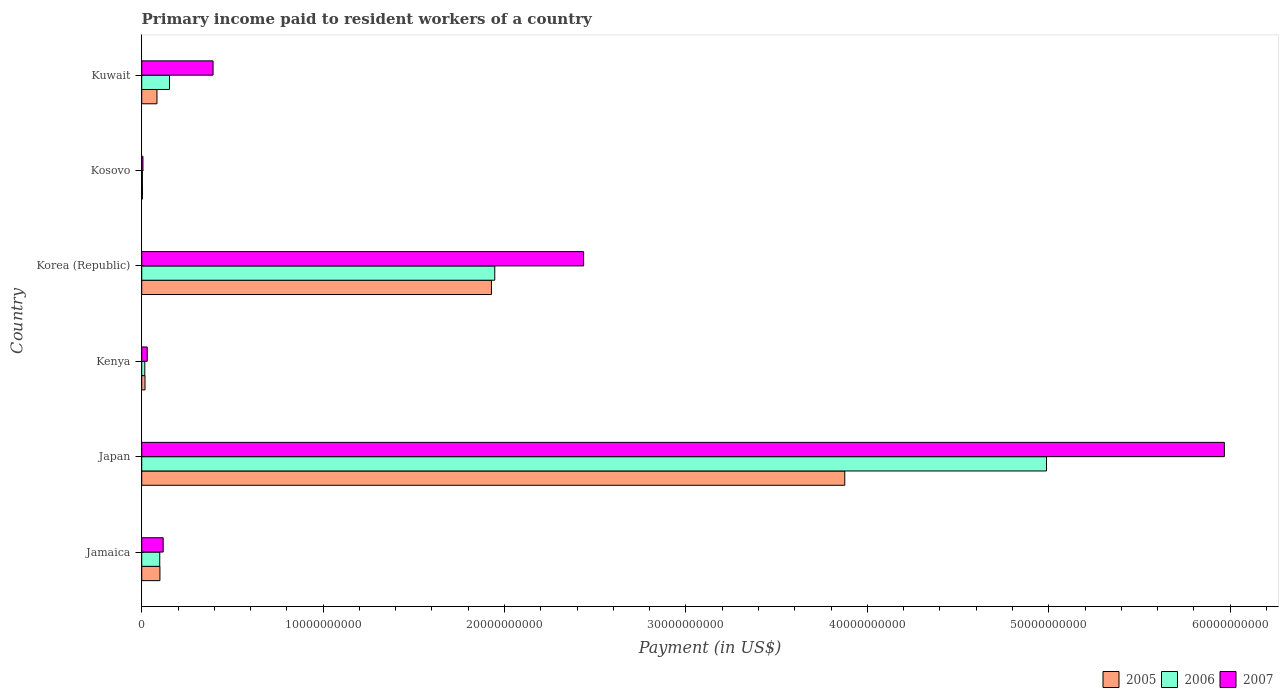How many groups of bars are there?
Your answer should be very brief. 6. Are the number of bars on each tick of the Y-axis equal?
Provide a succinct answer. Yes. How many bars are there on the 6th tick from the bottom?
Your answer should be compact. 3. What is the label of the 6th group of bars from the top?
Provide a succinct answer. Jamaica. What is the amount paid to workers in 2006 in Kosovo?
Give a very brief answer. 3.64e+07. Across all countries, what is the maximum amount paid to workers in 2007?
Your answer should be very brief. 5.97e+1. Across all countries, what is the minimum amount paid to workers in 2007?
Your answer should be compact. 6.76e+07. In which country was the amount paid to workers in 2005 minimum?
Provide a short and direct response. Kosovo. What is the total amount paid to workers in 2007 in the graph?
Make the answer very short. 8.95e+1. What is the difference between the amount paid to workers in 2006 in Japan and that in Kenya?
Your response must be concise. 4.97e+1. What is the difference between the amount paid to workers in 2005 in Japan and the amount paid to workers in 2007 in Jamaica?
Make the answer very short. 3.76e+1. What is the average amount paid to workers in 2006 per country?
Offer a terse response. 1.20e+1. What is the difference between the amount paid to workers in 2006 and amount paid to workers in 2005 in Kosovo?
Give a very brief answer. -2.61e+06. What is the ratio of the amount paid to workers in 2005 in Jamaica to that in Korea (Republic)?
Provide a succinct answer. 0.05. Is the amount paid to workers in 2007 in Kosovo less than that in Kuwait?
Ensure brevity in your answer.  Yes. Is the difference between the amount paid to workers in 2006 in Korea (Republic) and Kuwait greater than the difference between the amount paid to workers in 2005 in Korea (Republic) and Kuwait?
Give a very brief answer. No. What is the difference between the highest and the second highest amount paid to workers in 2006?
Offer a very short reply. 3.04e+1. What is the difference between the highest and the lowest amount paid to workers in 2005?
Offer a terse response. 3.87e+1. In how many countries, is the amount paid to workers in 2007 greater than the average amount paid to workers in 2007 taken over all countries?
Give a very brief answer. 2. Is the sum of the amount paid to workers in 2006 in Japan and Korea (Republic) greater than the maximum amount paid to workers in 2005 across all countries?
Keep it short and to the point. Yes. What does the 1st bar from the top in Kuwait represents?
Make the answer very short. 2007. Is it the case that in every country, the sum of the amount paid to workers in 2005 and amount paid to workers in 2006 is greater than the amount paid to workers in 2007?
Offer a very short reply. No. How many bars are there?
Your answer should be very brief. 18. Are all the bars in the graph horizontal?
Ensure brevity in your answer.  Yes. Are the values on the major ticks of X-axis written in scientific E-notation?
Give a very brief answer. No. What is the title of the graph?
Your answer should be very brief. Primary income paid to resident workers of a country. What is the label or title of the X-axis?
Provide a succinct answer. Payment (in US$). What is the label or title of the Y-axis?
Offer a terse response. Country. What is the Payment (in US$) of 2005 in Jamaica?
Your response must be concise. 1.00e+09. What is the Payment (in US$) in 2006 in Jamaica?
Your answer should be compact. 9.94e+08. What is the Payment (in US$) of 2007 in Jamaica?
Keep it short and to the point. 1.18e+09. What is the Payment (in US$) of 2005 in Japan?
Give a very brief answer. 3.88e+1. What is the Payment (in US$) of 2006 in Japan?
Provide a short and direct response. 4.99e+1. What is the Payment (in US$) in 2007 in Japan?
Your answer should be very brief. 5.97e+1. What is the Payment (in US$) of 2005 in Kenya?
Make the answer very short. 1.82e+08. What is the Payment (in US$) of 2006 in Kenya?
Keep it short and to the point. 1.70e+08. What is the Payment (in US$) in 2007 in Kenya?
Keep it short and to the point. 3.05e+08. What is the Payment (in US$) of 2005 in Korea (Republic)?
Give a very brief answer. 1.93e+1. What is the Payment (in US$) of 2006 in Korea (Republic)?
Provide a succinct answer. 1.95e+1. What is the Payment (in US$) in 2007 in Korea (Republic)?
Provide a short and direct response. 2.44e+1. What is the Payment (in US$) in 2005 in Kosovo?
Keep it short and to the point. 3.90e+07. What is the Payment (in US$) in 2006 in Kosovo?
Ensure brevity in your answer.  3.64e+07. What is the Payment (in US$) of 2007 in Kosovo?
Your answer should be compact. 6.76e+07. What is the Payment (in US$) in 2005 in Kuwait?
Give a very brief answer. 8.41e+08. What is the Payment (in US$) in 2006 in Kuwait?
Provide a succinct answer. 1.53e+09. What is the Payment (in US$) in 2007 in Kuwait?
Provide a short and direct response. 3.93e+09. Across all countries, what is the maximum Payment (in US$) of 2005?
Make the answer very short. 3.88e+1. Across all countries, what is the maximum Payment (in US$) of 2006?
Keep it short and to the point. 4.99e+1. Across all countries, what is the maximum Payment (in US$) of 2007?
Your answer should be very brief. 5.97e+1. Across all countries, what is the minimum Payment (in US$) in 2005?
Give a very brief answer. 3.90e+07. Across all countries, what is the minimum Payment (in US$) of 2006?
Provide a short and direct response. 3.64e+07. Across all countries, what is the minimum Payment (in US$) of 2007?
Make the answer very short. 6.76e+07. What is the total Payment (in US$) in 2005 in the graph?
Your answer should be very brief. 6.01e+1. What is the total Payment (in US$) in 2006 in the graph?
Ensure brevity in your answer.  7.21e+1. What is the total Payment (in US$) in 2007 in the graph?
Your answer should be compact. 8.95e+1. What is the difference between the Payment (in US$) of 2005 in Jamaica and that in Japan?
Offer a terse response. -3.77e+1. What is the difference between the Payment (in US$) in 2006 in Jamaica and that in Japan?
Give a very brief answer. -4.89e+1. What is the difference between the Payment (in US$) in 2007 in Jamaica and that in Japan?
Provide a short and direct response. -5.85e+1. What is the difference between the Payment (in US$) in 2005 in Jamaica and that in Kenya?
Provide a short and direct response. 8.22e+08. What is the difference between the Payment (in US$) in 2006 in Jamaica and that in Kenya?
Provide a succinct answer. 8.25e+08. What is the difference between the Payment (in US$) of 2007 in Jamaica and that in Kenya?
Offer a terse response. 8.78e+08. What is the difference between the Payment (in US$) of 2005 in Jamaica and that in Korea (Republic)?
Ensure brevity in your answer.  -1.83e+1. What is the difference between the Payment (in US$) of 2006 in Jamaica and that in Korea (Republic)?
Offer a very short reply. -1.85e+1. What is the difference between the Payment (in US$) of 2007 in Jamaica and that in Korea (Republic)?
Offer a very short reply. -2.32e+1. What is the difference between the Payment (in US$) in 2005 in Jamaica and that in Kosovo?
Provide a short and direct response. 9.65e+08. What is the difference between the Payment (in US$) in 2006 in Jamaica and that in Kosovo?
Your answer should be compact. 9.58e+08. What is the difference between the Payment (in US$) in 2007 in Jamaica and that in Kosovo?
Your answer should be very brief. 1.11e+09. What is the difference between the Payment (in US$) in 2005 in Jamaica and that in Kuwait?
Ensure brevity in your answer.  1.63e+08. What is the difference between the Payment (in US$) in 2006 in Jamaica and that in Kuwait?
Offer a terse response. -5.38e+08. What is the difference between the Payment (in US$) in 2007 in Jamaica and that in Kuwait?
Make the answer very short. -2.75e+09. What is the difference between the Payment (in US$) in 2005 in Japan and that in Kenya?
Your response must be concise. 3.86e+1. What is the difference between the Payment (in US$) in 2006 in Japan and that in Kenya?
Your answer should be very brief. 4.97e+1. What is the difference between the Payment (in US$) in 2007 in Japan and that in Kenya?
Your answer should be very brief. 5.94e+1. What is the difference between the Payment (in US$) in 2005 in Japan and that in Korea (Republic)?
Your answer should be very brief. 1.95e+1. What is the difference between the Payment (in US$) of 2006 in Japan and that in Korea (Republic)?
Provide a short and direct response. 3.04e+1. What is the difference between the Payment (in US$) of 2007 in Japan and that in Korea (Republic)?
Your response must be concise. 3.53e+1. What is the difference between the Payment (in US$) of 2005 in Japan and that in Kosovo?
Your answer should be compact. 3.87e+1. What is the difference between the Payment (in US$) of 2006 in Japan and that in Kosovo?
Your answer should be compact. 4.98e+1. What is the difference between the Payment (in US$) of 2007 in Japan and that in Kosovo?
Keep it short and to the point. 5.96e+1. What is the difference between the Payment (in US$) in 2005 in Japan and that in Kuwait?
Provide a succinct answer. 3.79e+1. What is the difference between the Payment (in US$) of 2006 in Japan and that in Kuwait?
Provide a succinct answer. 4.83e+1. What is the difference between the Payment (in US$) of 2007 in Japan and that in Kuwait?
Offer a very short reply. 5.57e+1. What is the difference between the Payment (in US$) in 2005 in Kenya and that in Korea (Republic)?
Your answer should be compact. -1.91e+1. What is the difference between the Payment (in US$) in 2006 in Kenya and that in Korea (Republic)?
Make the answer very short. -1.93e+1. What is the difference between the Payment (in US$) in 2007 in Kenya and that in Korea (Republic)?
Your answer should be compact. -2.41e+1. What is the difference between the Payment (in US$) in 2005 in Kenya and that in Kosovo?
Make the answer very short. 1.43e+08. What is the difference between the Payment (in US$) in 2006 in Kenya and that in Kosovo?
Offer a terse response. 1.33e+08. What is the difference between the Payment (in US$) of 2007 in Kenya and that in Kosovo?
Your answer should be compact. 2.37e+08. What is the difference between the Payment (in US$) in 2005 in Kenya and that in Kuwait?
Your answer should be compact. -6.59e+08. What is the difference between the Payment (in US$) in 2006 in Kenya and that in Kuwait?
Keep it short and to the point. -1.36e+09. What is the difference between the Payment (in US$) in 2007 in Kenya and that in Kuwait?
Your answer should be compact. -3.63e+09. What is the difference between the Payment (in US$) in 2005 in Korea (Republic) and that in Kosovo?
Give a very brief answer. 1.92e+1. What is the difference between the Payment (in US$) of 2006 in Korea (Republic) and that in Kosovo?
Provide a short and direct response. 1.94e+1. What is the difference between the Payment (in US$) in 2007 in Korea (Republic) and that in Kosovo?
Offer a terse response. 2.43e+1. What is the difference between the Payment (in US$) in 2005 in Korea (Republic) and that in Kuwait?
Offer a terse response. 1.84e+1. What is the difference between the Payment (in US$) of 2006 in Korea (Republic) and that in Kuwait?
Your answer should be very brief. 1.79e+1. What is the difference between the Payment (in US$) of 2007 in Korea (Republic) and that in Kuwait?
Provide a short and direct response. 2.04e+1. What is the difference between the Payment (in US$) of 2005 in Kosovo and that in Kuwait?
Give a very brief answer. -8.02e+08. What is the difference between the Payment (in US$) in 2006 in Kosovo and that in Kuwait?
Offer a terse response. -1.50e+09. What is the difference between the Payment (in US$) of 2007 in Kosovo and that in Kuwait?
Ensure brevity in your answer.  -3.86e+09. What is the difference between the Payment (in US$) of 2005 in Jamaica and the Payment (in US$) of 2006 in Japan?
Your response must be concise. -4.89e+1. What is the difference between the Payment (in US$) of 2005 in Jamaica and the Payment (in US$) of 2007 in Japan?
Keep it short and to the point. -5.87e+1. What is the difference between the Payment (in US$) in 2006 in Jamaica and the Payment (in US$) in 2007 in Japan?
Provide a succinct answer. -5.87e+1. What is the difference between the Payment (in US$) of 2005 in Jamaica and the Payment (in US$) of 2006 in Kenya?
Your response must be concise. 8.35e+08. What is the difference between the Payment (in US$) of 2005 in Jamaica and the Payment (in US$) of 2007 in Kenya?
Make the answer very short. 6.99e+08. What is the difference between the Payment (in US$) of 2006 in Jamaica and the Payment (in US$) of 2007 in Kenya?
Your answer should be compact. 6.89e+08. What is the difference between the Payment (in US$) in 2005 in Jamaica and the Payment (in US$) in 2006 in Korea (Republic)?
Your answer should be compact. -1.85e+1. What is the difference between the Payment (in US$) of 2005 in Jamaica and the Payment (in US$) of 2007 in Korea (Republic)?
Give a very brief answer. -2.34e+1. What is the difference between the Payment (in US$) in 2006 in Jamaica and the Payment (in US$) in 2007 in Korea (Republic)?
Provide a short and direct response. -2.34e+1. What is the difference between the Payment (in US$) in 2005 in Jamaica and the Payment (in US$) in 2006 in Kosovo?
Provide a short and direct response. 9.68e+08. What is the difference between the Payment (in US$) in 2005 in Jamaica and the Payment (in US$) in 2007 in Kosovo?
Keep it short and to the point. 9.37e+08. What is the difference between the Payment (in US$) of 2006 in Jamaica and the Payment (in US$) of 2007 in Kosovo?
Offer a very short reply. 9.26e+08. What is the difference between the Payment (in US$) in 2005 in Jamaica and the Payment (in US$) in 2006 in Kuwait?
Your response must be concise. -5.28e+08. What is the difference between the Payment (in US$) of 2005 in Jamaica and the Payment (in US$) of 2007 in Kuwait?
Ensure brevity in your answer.  -2.93e+09. What is the difference between the Payment (in US$) in 2006 in Jamaica and the Payment (in US$) in 2007 in Kuwait?
Offer a very short reply. -2.94e+09. What is the difference between the Payment (in US$) of 2005 in Japan and the Payment (in US$) of 2006 in Kenya?
Give a very brief answer. 3.86e+1. What is the difference between the Payment (in US$) of 2005 in Japan and the Payment (in US$) of 2007 in Kenya?
Your answer should be compact. 3.84e+1. What is the difference between the Payment (in US$) in 2006 in Japan and the Payment (in US$) in 2007 in Kenya?
Offer a terse response. 4.96e+1. What is the difference between the Payment (in US$) in 2005 in Japan and the Payment (in US$) in 2006 in Korea (Republic)?
Ensure brevity in your answer.  1.93e+1. What is the difference between the Payment (in US$) of 2005 in Japan and the Payment (in US$) of 2007 in Korea (Republic)?
Offer a very short reply. 1.44e+1. What is the difference between the Payment (in US$) of 2006 in Japan and the Payment (in US$) of 2007 in Korea (Republic)?
Offer a very short reply. 2.55e+1. What is the difference between the Payment (in US$) of 2005 in Japan and the Payment (in US$) of 2006 in Kosovo?
Your response must be concise. 3.87e+1. What is the difference between the Payment (in US$) in 2005 in Japan and the Payment (in US$) in 2007 in Kosovo?
Your answer should be compact. 3.87e+1. What is the difference between the Payment (in US$) in 2006 in Japan and the Payment (in US$) in 2007 in Kosovo?
Your answer should be very brief. 4.98e+1. What is the difference between the Payment (in US$) of 2005 in Japan and the Payment (in US$) of 2006 in Kuwait?
Your response must be concise. 3.72e+1. What is the difference between the Payment (in US$) in 2005 in Japan and the Payment (in US$) in 2007 in Kuwait?
Offer a very short reply. 3.48e+1. What is the difference between the Payment (in US$) in 2006 in Japan and the Payment (in US$) in 2007 in Kuwait?
Provide a succinct answer. 4.59e+1. What is the difference between the Payment (in US$) of 2005 in Kenya and the Payment (in US$) of 2006 in Korea (Republic)?
Your response must be concise. -1.93e+1. What is the difference between the Payment (in US$) in 2005 in Kenya and the Payment (in US$) in 2007 in Korea (Republic)?
Give a very brief answer. -2.42e+1. What is the difference between the Payment (in US$) of 2006 in Kenya and the Payment (in US$) of 2007 in Korea (Republic)?
Keep it short and to the point. -2.42e+1. What is the difference between the Payment (in US$) in 2005 in Kenya and the Payment (in US$) in 2006 in Kosovo?
Provide a short and direct response. 1.45e+08. What is the difference between the Payment (in US$) in 2005 in Kenya and the Payment (in US$) in 2007 in Kosovo?
Provide a succinct answer. 1.14e+08. What is the difference between the Payment (in US$) in 2006 in Kenya and the Payment (in US$) in 2007 in Kosovo?
Your answer should be compact. 1.02e+08. What is the difference between the Payment (in US$) of 2005 in Kenya and the Payment (in US$) of 2006 in Kuwait?
Your response must be concise. -1.35e+09. What is the difference between the Payment (in US$) in 2005 in Kenya and the Payment (in US$) in 2007 in Kuwait?
Make the answer very short. -3.75e+09. What is the difference between the Payment (in US$) of 2006 in Kenya and the Payment (in US$) of 2007 in Kuwait?
Provide a short and direct response. -3.76e+09. What is the difference between the Payment (in US$) in 2005 in Korea (Republic) and the Payment (in US$) in 2006 in Kosovo?
Provide a succinct answer. 1.92e+1. What is the difference between the Payment (in US$) of 2005 in Korea (Republic) and the Payment (in US$) of 2007 in Kosovo?
Your response must be concise. 1.92e+1. What is the difference between the Payment (in US$) in 2006 in Korea (Republic) and the Payment (in US$) in 2007 in Kosovo?
Ensure brevity in your answer.  1.94e+1. What is the difference between the Payment (in US$) in 2005 in Korea (Republic) and the Payment (in US$) in 2006 in Kuwait?
Ensure brevity in your answer.  1.77e+1. What is the difference between the Payment (in US$) in 2005 in Korea (Republic) and the Payment (in US$) in 2007 in Kuwait?
Your answer should be very brief. 1.53e+1. What is the difference between the Payment (in US$) of 2006 in Korea (Republic) and the Payment (in US$) of 2007 in Kuwait?
Ensure brevity in your answer.  1.55e+1. What is the difference between the Payment (in US$) in 2005 in Kosovo and the Payment (in US$) in 2006 in Kuwait?
Make the answer very short. -1.49e+09. What is the difference between the Payment (in US$) in 2005 in Kosovo and the Payment (in US$) in 2007 in Kuwait?
Provide a short and direct response. -3.89e+09. What is the difference between the Payment (in US$) of 2006 in Kosovo and the Payment (in US$) of 2007 in Kuwait?
Give a very brief answer. -3.90e+09. What is the average Payment (in US$) in 2005 per country?
Keep it short and to the point. 1.00e+1. What is the average Payment (in US$) of 2006 per country?
Provide a short and direct response. 1.20e+1. What is the average Payment (in US$) of 2007 per country?
Keep it short and to the point. 1.49e+1. What is the difference between the Payment (in US$) in 2005 and Payment (in US$) in 2006 in Jamaica?
Ensure brevity in your answer.  1.01e+07. What is the difference between the Payment (in US$) of 2005 and Payment (in US$) of 2007 in Jamaica?
Keep it short and to the point. -1.78e+08. What is the difference between the Payment (in US$) of 2006 and Payment (in US$) of 2007 in Jamaica?
Make the answer very short. -1.88e+08. What is the difference between the Payment (in US$) of 2005 and Payment (in US$) of 2006 in Japan?
Make the answer very short. -1.11e+1. What is the difference between the Payment (in US$) in 2005 and Payment (in US$) in 2007 in Japan?
Provide a short and direct response. -2.09e+1. What is the difference between the Payment (in US$) in 2006 and Payment (in US$) in 2007 in Japan?
Ensure brevity in your answer.  -9.80e+09. What is the difference between the Payment (in US$) in 2005 and Payment (in US$) in 2006 in Kenya?
Offer a very short reply. 1.22e+07. What is the difference between the Payment (in US$) of 2005 and Payment (in US$) of 2007 in Kenya?
Ensure brevity in your answer.  -1.23e+08. What is the difference between the Payment (in US$) of 2006 and Payment (in US$) of 2007 in Kenya?
Provide a short and direct response. -1.35e+08. What is the difference between the Payment (in US$) of 2005 and Payment (in US$) of 2006 in Korea (Republic)?
Ensure brevity in your answer.  -1.84e+08. What is the difference between the Payment (in US$) of 2005 and Payment (in US$) of 2007 in Korea (Republic)?
Give a very brief answer. -5.08e+09. What is the difference between the Payment (in US$) of 2006 and Payment (in US$) of 2007 in Korea (Republic)?
Make the answer very short. -4.90e+09. What is the difference between the Payment (in US$) in 2005 and Payment (in US$) in 2006 in Kosovo?
Keep it short and to the point. 2.61e+06. What is the difference between the Payment (in US$) in 2005 and Payment (in US$) in 2007 in Kosovo?
Make the answer very short. -2.86e+07. What is the difference between the Payment (in US$) in 2006 and Payment (in US$) in 2007 in Kosovo?
Give a very brief answer. -3.12e+07. What is the difference between the Payment (in US$) in 2005 and Payment (in US$) in 2006 in Kuwait?
Your answer should be compact. -6.92e+08. What is the difference between the Payment (in US$) of 2005 and Payment (in US$) of 2007 in Kuwait?
Provide a short and direct response. -3.09e+09. What is the difference between the Payment (in US$) in 2006 and Payment (in US$) in 2007 in Kuwait?
Keep it short and to the point. -2.40e+09. What is the ratio of the Payment (in US$) in 2005 in Jamaica to that in Japan?
Give a very brief answer. 0.03. What is the ratio of the Payment (in US$) in 2006 in Jamaica to that in Japan?
Your answer should be compact. 0.02. What is the ratio of the Payment (in US$) of 2007 in Jamaica to that in Japan?
Your answer should be compact. 0.02. What is the ratio of the Payment (in US$) of 2005 in Jamaica to that in Kenya?
Your answer should be compact. 5.53. What is the ratio of the Payment (in US$) in 2006 in Jamaica to that in Kenya?
Your response must be concise. 5.86. What is the ratio of the Payment (in US$) in 2007 in Jamaica to that in Kenya?
Provide a succinct answer. 3.88. What is the ratio of the Payment (in US$) of 2005 in Jamaica to that in Korea (Republic)?
Give a very brief answer. 0.05. What is the ratio of the Payment (in US$) of 2006 in Jamaica to that in Korea (Republic)?
Make the answer very short. 0.05. What is the ratio of the Payment (in US$) of 2007 in Jamaica to that in Korea (Republic)?
Make the answer very short. 0.05. What is the ratio of the Payment (in US$) of 2005 in Jamaica to that in Kosovo?
Ensure brevity in your answer.  25.73. What is the ratio of the Payment (in US$) in 2006 in Jamaica to that in Kosovo?
Your response must be concise. 27.29. What is the ratio of the Payment (in US$) in 2007 in Jamaica to that in Kosovo?
Make the answer very short. 17.48. What is the ratio of the Payment (in US$) in 2005 in Jamaica to that in Kuwait?
Offer a terse response. 1.19. What is the ratio of the Payment (in US$) in 2006 in Jamaica to that in Kuwait?
Ensure brevity in your answer.  0.65. What is the ratio of the Payment (in US$) of 2007 in Jamaica to that in Kuwait?
Provide a succinct answer. 0.3. What is the ratio of the Payment (in US$) in 2005 in Japan to that in Kenya?
Make the answer very short. 213.25. What is the ratio of the Payment (in US$) of 2006 in Japan to that in Kenya?
Offer a terse response. 294.23. What is the ratio of the Payment (in US$) in 2007 in Japan to that in Kenya?
Your answer should be very brief. 195.79. What is the ratio of the Payment (in US$) in 2005 in Japan to that in Korea (Republic)?
Your answer should be compact. 2.01. What is the ratio of the Payment (in US$) of 2006 in Japan to that in Korea (Republic)?
Offer a very short reply. 2.56. What is the ratio of the Payment (in US$) in 2007 in Japan to that in Korea (Republic)?
Offer a very short reply. 2.45. What is the ratio of the Payment (in US$) of 2005 in Japan to that in Kosovo?
Provide a short and direct response. 993.04. What is the ratio of the Payment (in US$) in 2006 in Japan to that in Kosovo?
Your answer should be very brief. 1369.46. What is the ratio of the Payment (in US$) of 2007 in Japan to that in Kosovo?
Give a very brief answer. 882.37. What is the ratio of the Payment (in US$) in 2005 in Japan to that in Kuwait?
Provide a short and direct response. 46.09. What is the ratio of the Payment (in US$) of 2006 in Japan to that in Kuwait?
Provide a short and direct response. 32.54. What is the ratio of the Payment (in US$) in 2007 in Japan to that in Kuwait?
Offer a very short reply. 15.18. What is the ratio of the Payment (in US$) of 2005 in Kenya to that in Korea (Republic)?
Your answer should be very brief. 0.01. What is the ratio of the Payment (in US$) in 2006 in Kenya to that in Korea (Republic)?
Your response must be concise. 0.01. What is the ratio of the Payment (in US$) in 2007 in Kenya to that in Korea (Republic)?
Ensure brevity in your answer.  0.01. What is the ratio of the Payment (in US$) of 2005 in Kenya to that in Kosovo?
Ensure brevity in your answer.  4.66. What is the ratio of the Payment (in US$) of 2006 in Kenya to that in Kosovo?
Your response must be concise. 4.65. What is the ratio of the Payment (in US$) of 2007 in Kenya to that in Kosovo?
Provide a short and direct response. 4.51. What is the ratio of the Payment (in US$) of 2005 in Kenya to that in Kuwait?
Your response must be concise. 0.22. What is the ratio of the Payment (in US$) of 2006 in Kenya to that in Kuwait?
Your answer should be compact. 0.11. What is the ratio of the Payment (in US$) in 2007 in Kenya to that in Kuwait?
Keep it short and to the point. 0.08. What is the ratio of the Payment (in US$) in 2005 in Korea (Republic) to that in Kosovo?
Ensure brevity in your answer.  493.97. What is the ratio of the Payment (in US$) in 2006 in Korea (Republic) to that in Kosovo?
Your answer should be compact. 534.36. What is the ratio of the Payment (in US$) of 2007 in Korea (Republic) to that in Kosovo?
Give a very brief answer. 360.16. What is the ratio of the Payment (in US$) of 2005 in Korea (Republic) to that in Kuwait?
Give a very brief answer. 22.93. What is the ratio of the Payment (in US$) of 2006 in Korea (Republic) to that in Kuwait?
Your response must be concise. 12.7. What is the ratio of the Payment (in US$) in 2007 in Korea (Republic) to that in Kuwait?
Provide a succinct answer. 6.19. What is the ratio of the Payment (in US$) in 2005 in Kosovo to that in Kuwait?
Keep it short and to the point. 0.05. What is the ratio of the Payment (in US$) in 2006 in Kosovo to that in Kuwait?
Offer a very short reply. 0.02. What is the ratio of the Payment (in US$) of 2007 in Kosovo to that in Kuwait?
Offer a terse response. 0.02. What is the difference between the highest and the second highest Payment (in US$) of 2005?
Offer a terse response. 1.95e+1. What is the difference between the highest and the second highest Payment (in US$) in 2006?
Keep it short and to the point. 3.04e+1. What is the difference between the highest and the second highest Payment (in US$) of 2007?
Make the answer very short. 3.53e+1. What is the difference between the highest and the lowest Payment (in US$) of 2005?
Ensure brevity in your answer.  3.87e+1. What is the difference between the highest and the lowest Payment (in US$) in 2006?
Your response must be concise. 4.98e+1. What is the difference between the highest and the lowest Payment (in US$) in 2007?
Offer a very short reply. 5.96e+1. 